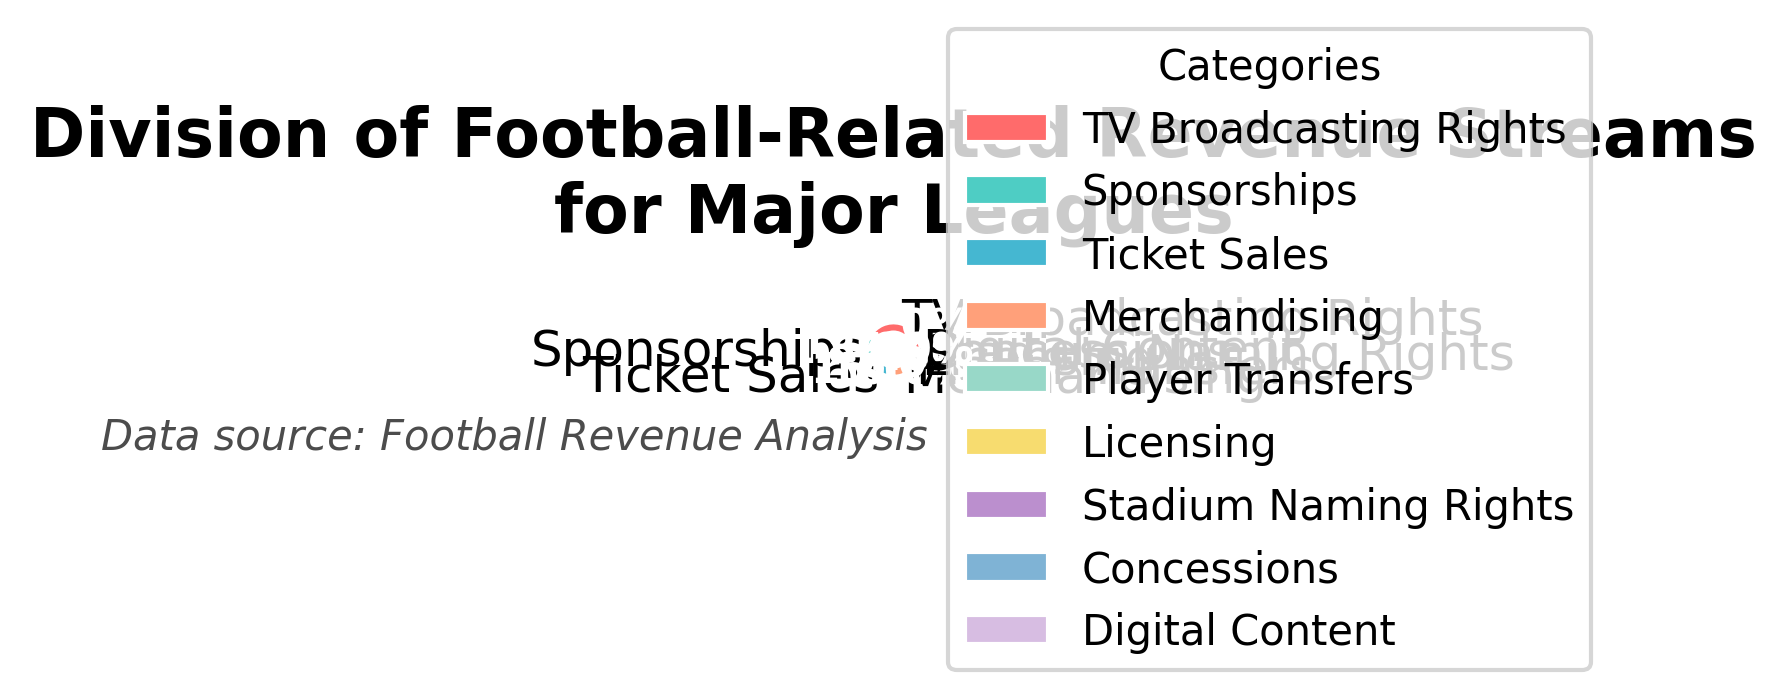What percentage of revenue comes from TV Broadcasting Rights? The TV Broadcasting Rights slice is labeled directly with its percentage. The label shows 42%.
Answer: 42% Which revenue stream has the lowest percentage? The smallest slice in the pie chart corresponds to the Concessions category, labeled with 1%.
Answer: Concessions What is the combined percentage of revenue from TV Broadcasting Rights and Sponsorships? According to the chart, TV Broadcasting Rights are 42% and Sponsorships are 18%. Adding these percentages together gives 42% + 18% = 60%.
Answer: 60% Which categories together make up more than 50% of the revenue? TV Broadcasting Rights (42%) and Sponsorships (18%) together sum up to 60%, which is more than 50%. Hence, these two categories make up more than 50% of the revenue.
Answer: TV Broadcasting Rights and Sponsorships How does the revenue from Ticket Sales compare to the revenue from Merchandising? The pie chart shows that Ticket Sales account for 15%, while Merchandising stands at 10%. Ticket Sales (15%) are greater than Merchandising (10%).
Answer: Ticket Sales > Merchandising What is the percentage difference between Player Transfers and Licensing revenues? According to the chart, Player Transfers make up 7% of the revenue and Licensing accounts for 4%. The difference is calculated as 7% - 4% = 3%.
Answer: 3% Which category contributes more: Stadium Naming Rights or Digital Content? The pie chart indicates Stadium Naming Rights at 2% and Digital Content at 1%. Therefore, Stadium Naming Rights contribute more compared to Digital Content.
Answer: Stadium Naming Rights What is the total percentage of revenue from categories contributing less than 5% each? The categories contributing less than 5% are Licensing (4%), Stadium Naming Rights (2%), Concessions (1%), and Digital Content (1%). Adding these together results in 4% + 2% + 1% + 1% = 8%.
Answer: 8% How many categories capture exactly half of the total revenue? The closest combination to 50% from the pie chart is the sum of TV Broadcasting Rights (42%) and Ticket Sales (15%). However, the sum is 57%, over 50%. There’s no exact combination that adds up to 50%, but the closest is one category, TV Broadcasting Rights, at 42%, which is less.
Answer: 1 